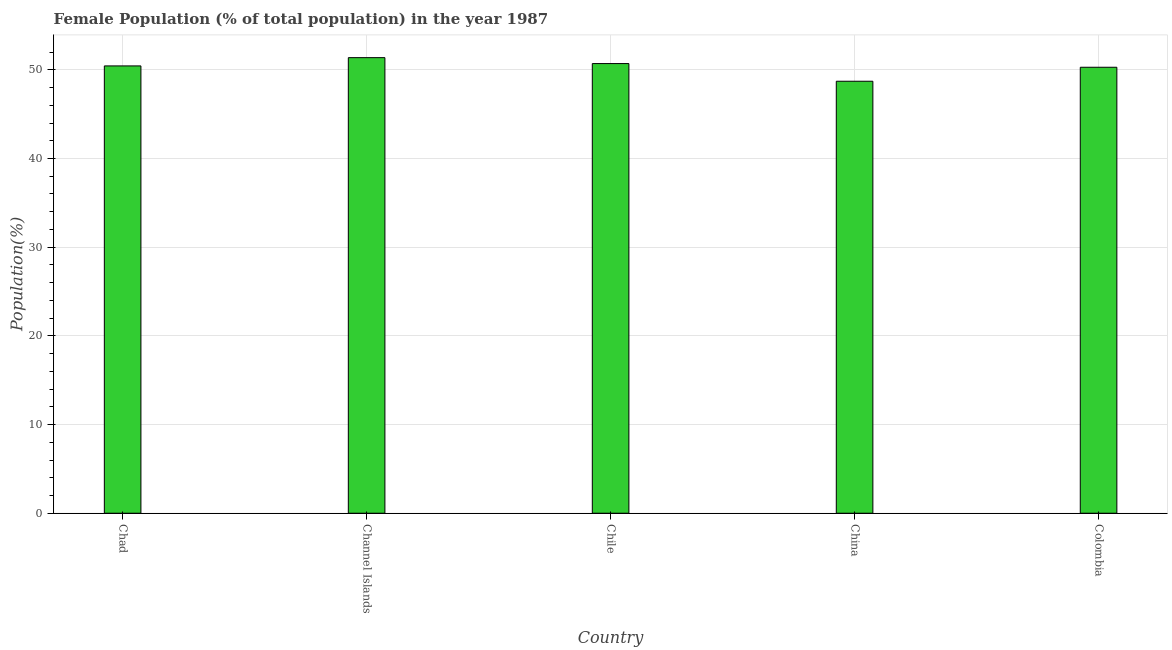Does the graph contain any zero values?
Offer a terse response. No. What is the title of the graph?
Your response must be concise. Female Population (% of total population) in the year 1987. What is the label or title of the Y-axis?
Your answer should be very brief. Population(%). What is the female population in Chad?
Keep it short and to the point. 50.44. Across all countries, what is the maximum female population?
Provide a short and direct response. 51.37. Across all countries, what is the minimum female population?
Your response must be concise. 48.71. In which country was the female population maximum?
Ensure brevity in your answer.  Channel Islands. What is the sum of the female population?
Make the answer very short. 251.51. What is the difference between the female population in Chad and Colombia?
Offer a very short reply. 0.15. What is the average female population per country?
Offer a terse response. 50.3. What is the median female population?
Offer a terse response. 50.44. What is the ratio of the female population in Channel Islands to that in China?
Provide a succinct answer. 1.05. Is the difference between the female population in Chile and Colombia greater than the difference between any two countries?
Give a very brief answer. No. What is the difference between the highest and the second highest female population?
Your answer should be very brief. 0.67. Is the sum of the female population in Chile and Colombia greater than the maximum female population across all countries?
Provide a short and direct response. Yes. What is the difference between the highest and the lowest female population?
Keep it short and to the point. 2.66. In how many countries, is the female population greater than the average female population taken over all countries?
Your answer should be compact. 3. How many bars are there?
Provide a succinct answer. 5. How many countries are there in the graph?
Ensure brevity in your answer.  5. Are the values on the major ticks of Y-axis written in scientific E-notation?
Provide a short and direct response. No. What is the Population(%) in Chad?
Your answer should be very brief. 50.44. What is the Population(%) of Channel Islands?
Keep it short and to the point. 51.37. What is the Population(%) in Chile?
Offer a very short reply. 50.7. What is the Population(%) of China?
Keep it short and to the point. 48.71. What is the Population(%) in Colombia?
Ensure brevity in your answer.  50.29. What is the difference between the Population(%) in Chad and Channel Islands?
Ensure brevity in your answer.  -0.93. What is the difference between the Population(%) in Chad and Chile?
Give a very brief answer. -0.26. What is the difference between the Population(%) in Chad and China?
Give a very brief answer. 1.73. What is the difference between the Population(%) in Chad and Colombia?
Make the answer very short. 0.15. What is the difference between the Population(%) in Channel Islands and Chile?
Offer a very short reply. 0.67. What is the difference between the Population(%) in Channel Islands and China?
Offer a terse response. 2.66. What is the difference between the Population(%) in Channel Islands and Colombia?
Keep it short and to the point. 1.08. What is the difference between the Population(%) in Chile and China?
Offer a very short reply. 1.99. What is the difference between the Population(%) in Chile and Colombia?
Your response must be concise. 0.42. What is the difference between the Population(%) in China and Colombia?
Provide a short and direct response. -1.58. What is the ratio of the Population(%) in Chad to that in China?
Give a very brief answer. 1.03. What is the ratio of the Population(%) in Chad to that in Colombia?
Offer a very short reply. 1. What is the ratio of the Population(%) in Channel Islands to that in Chile?
Your response must be concise. 1.01. What is the ratio of the Population(%) in Channel Islands to that in China?
Your answer should be very brief. 1.05. What is the ratio of the Population(%) in Channel Islands to that in Colombia?
Give a very brief answer. 1.02. What is the ratio of the Population(%) in Chile to that in China?
Keep it short and to the point. 1.04. 